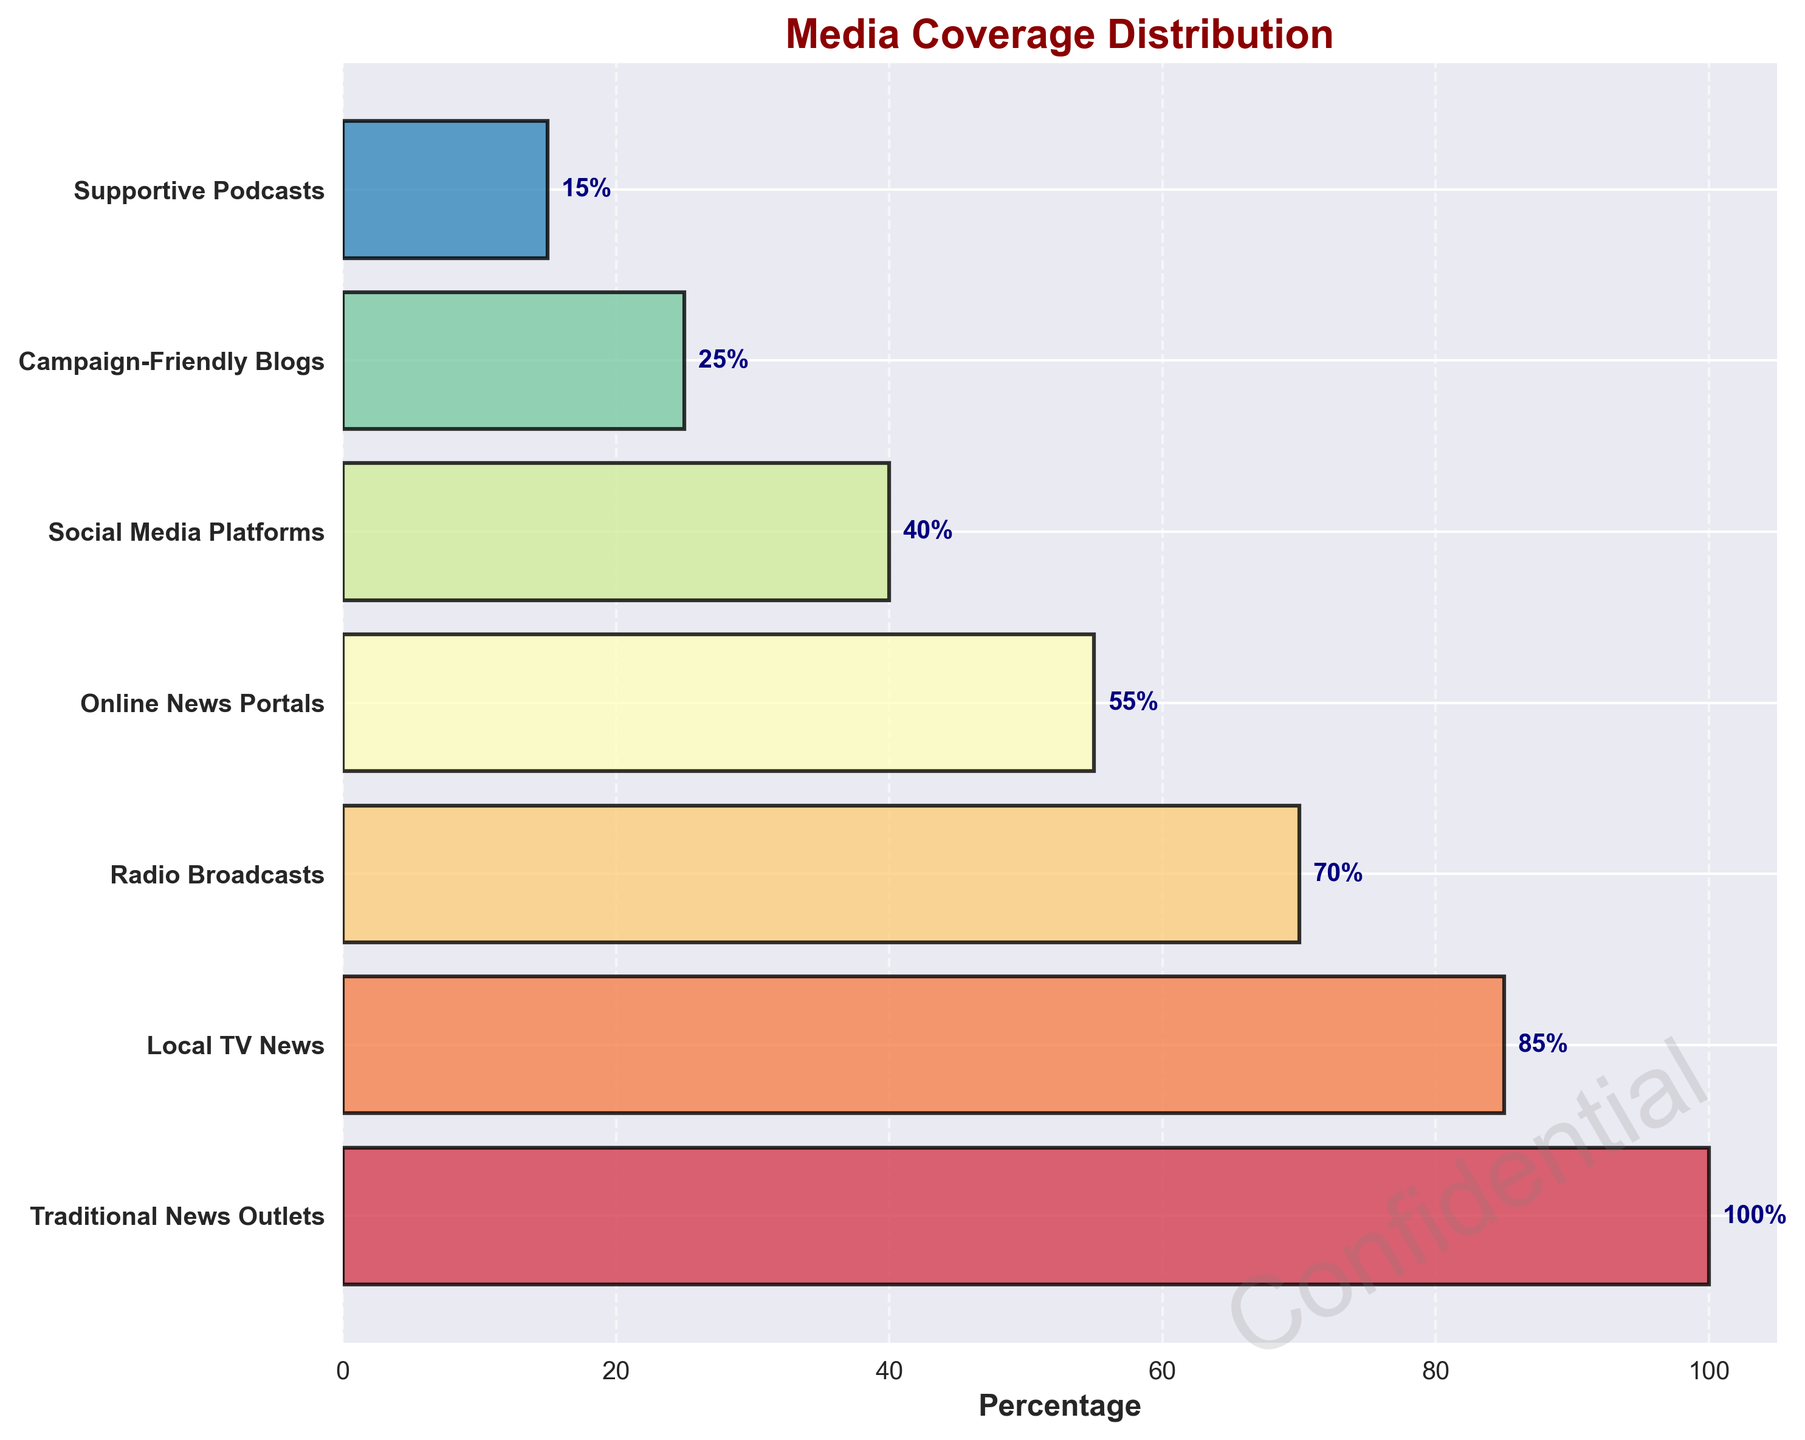What stage has the highest media coverage percentage? The highest media coverage percentage is located at the top of the funnel chart. Looking at the figure, the top stage is "Traditional News Outlets" with a percentage of 100%.
Answer: Traditional News Outlets What is the percentage difference between "Local TV News" and "Social Media Platforms"? Subtract the percentage of "Social Media Platforms" from the percentage of "Local TV News". This is 85% - 40% = 45%.
Answer: 45% How does the media coverage percentage of "Campaign-Friendly Blogs" compare to "Supportive Podcasts"? Compare the percentage values directly. "Campaign-Friendly Blogs" have 25% coverage while "Supportive Podcasts" have 15% coverage. Since 25% is greater than 15%, "Campaign-Friendly Blogs" have higher coverage.
Answer: Campaign-Friendly Blogs have higher coverage What is the total media coverage percentage for online platforms (Online News Portals and Social Media Platforms)? Add the percentages for the two stages related to online platforms: "Online News Portals" (55%) and "Social Media Platforms" (40%). The total is 55% + 40% = 95%.
Answer: 95% Which stage has the lowest media coverage percentage and what is that percentage? The lowest media coverage percentage is located at the bottom of the funnel chart. "Supportive Podcasts" is the stage at the bottom with a percentage of 15%.
Answer: Supportive Podcasts, 15% How many stages are there in the funnel chart? Count the number of distinct stages listed on the left side of the funnel chart. There are seven stages: Traditional News Outlets, Local TV News, Radio Broadcasts, Online News Portals, Social Media Platforms, Campaign-Friendly Blogs, and Supportive Podcasts.
Answer: 7 What is the percentage of media coverage in "Radio Broadcasts" relative to "Traditional News Outlets"? Divide the percentage of "Radio Broadcasts" by the percentage of "Traditional News Outlets". This is calculated as (70% / 100%)*100 = 70%.
Answer: 70% By how much does the media coverage percentage decrease from "Online News Portals" to "Campaign-Friendly Blogs"? Subtract the percentage of "Campaign-Friendly Blogs" from the percentage of "Online News Portals". This is 55% - 25% = 30%.
Answer: 30% Which stages have more than 50% media coverage? Look for stages with percentages higher than 50%. The stages above 50% are "Traditional News Outlets", "Local TV News", "Radio Broadcasts", and "Online News Portals".
Answer: Traditional News Outlets, Local TV News, Radio Broadcasts, Online News Portals What is the average media coverage percentage across all stages in the funnel chart? Sum up all the percentages and divide by the number of stages. (100% + 85% + 70% + 55% + 40% + 25% + 15%) / 7 = 390% / 7 ≈ 55.71%.
Answer: 55.71% 